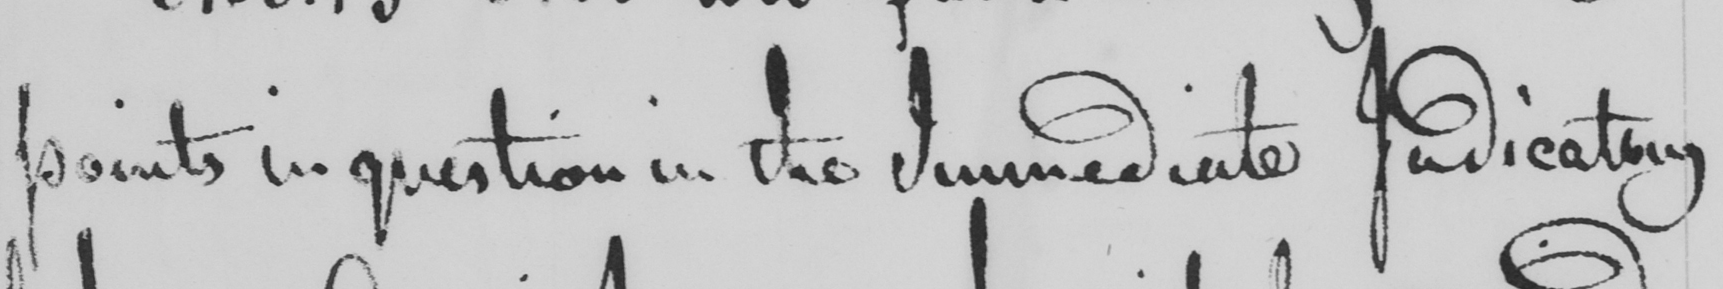What does this handwritten line say? points in question in the Immediate Judicatory 